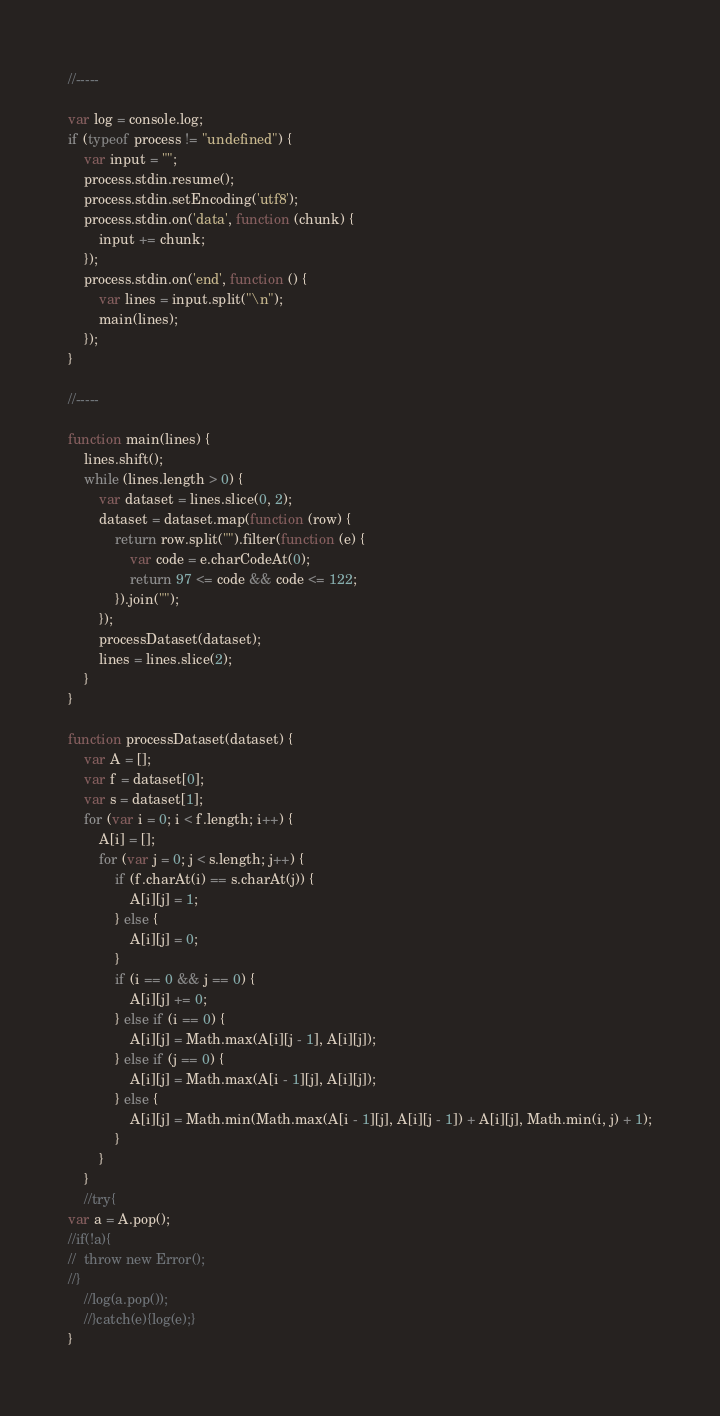<code> <loc_0><loc_0><loc_500><loc_500><_JavaScript_>//-----

var log = console.log;
if (typeof process != "undefined") {
	var input = "";
	process.stdin.resume();
	process.stdin.setEncoding('utf8');
	process.stdin.on('data', function (chunk) {
		input += chunk;
	});
	process.stdin.on('end', function () {
		var lines = input.split("\n");
		main(lines);
	});
}

//-----

function main(lines) {
	lines.shift();
	while (lines.length > 0) {
		var dataset = lines.slice(0, 2);
		dataset = dataset.map(function (row) {
			return row.split("").filter(function (e) {
				var code = e.charCodeAt(0);
				return 97 <= code && code <= 122;
			}).join("");
		});
		processDataset(dataset);
		lines = lines.slice(2);
	}
}

function processDataset(dataset) {
	var A = [];
	var f = dataset[0];
	var s = dataset[1];
	for (var i = 0; i < f.length; i++) {
		A[i] = [];
		for (var j = 0; j < s.length; j++) {
			if (f.charAt(i) == s.charAt(j)) {
				A[i][j] = 1;
			} else {
				A[i][j] = 0;
			}
			if (i == 0 && j == 0) {
				A[i][j] += 0;
			} else if (i == 0) {
				A[i][j] = Math.max(A[i][j - 1], A[i][j]);
			} else if (j == 0) {
				A[i][j] = Math.max(A[i - 1][j], A[i][j]);
			} else {
				A[i][j] = Math.min(Math.max(A[i - 1][j], A[i][j - 1]) + A[i][j], Math.min(i, j) + 1);
			}
		}
	}
	//try{
var a = A.pop();
//if(!a){
//  throw new Error();
//}
	//log(a.pop());
	//}catch(e){log(e);}
}</code> 